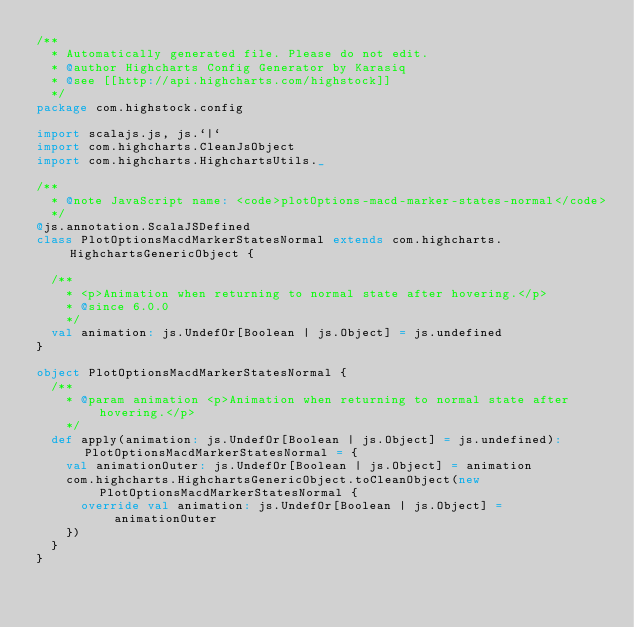<code> <loc_0><loc_0><loc_500><loc_500><_Scala_>/**
  * Automatically generated file. Please do not edit.
  * @author Highcharts Config Generator by Karasiq
  * @see [[http://api.highcharts.com/highstock]]
  */
package com.highstock.config

import scalajs.js, js.`|`
import com.highcharts.CleanJsObject
import com.highcharts.HighchartsUtils._

/**
  * @note JavaScript name: <code>plotOptions-macd-marker-states-normal</code>
  */
@js.annotation.ScalaJSDefined
class PlotOptionsMacdMarkerStatesNormal extends com.highcharts.HighchartsGenericObject {

  /**
    * <p>Animation when returning to normal state after hovering.</p>
    * @since 6.0.0
    */
  val animation: js.UndefOr[Boolean | js.Object] = js.undefined
}

object PlotOptionsMacdMarkerStatesNormal {
  /**
    * @param animation <p>Animation when returning to normal state after hovering.</p>
    */
  def apply(animation: js.UndefOr[Boolean | js.Object] = js.undefined): PlotOptionsMacdMarkerStatesNormal = {
    val animationOuter: js.UndefOr[Boolean | js.Object] = animation
    com.highcharts.HighchartsGenericObject.toCleanObject(new PlotOptionsMacdMarkerStatesNormal {
      override val animation: js.UndefOr[Boolean | js.Object] = animationOuter
    })
  }
}
</code> 